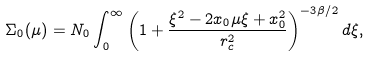<formula> <loc_0><loc_0><loc_500><loc_500>\Sigma _ { 0 } ( \mu ) = N _ { 0 } \int _ { 0 } ^ { \infty } { \left ( 1 + \frac { \xi ^ { 2 } - 2 x _ { 0 } \mu \xi + x _ { 0 } ^ { 2 } } { r _ { c } ^ { 2 } } \right ) ^ { - 3 \beta / 2 } d \xi } ,</formula> 